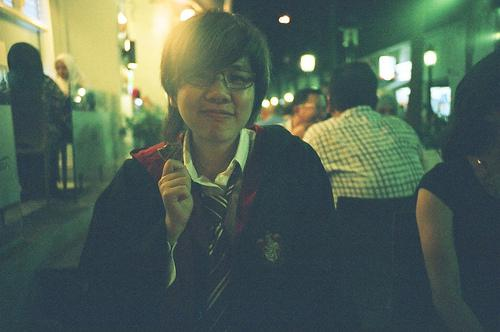Question: what is on her nose?
Choices:
A. Nose ring.
B. Tattoo.
C. Eyeglasses.
D. Her finger.
Answer with the letter. Answer: C 